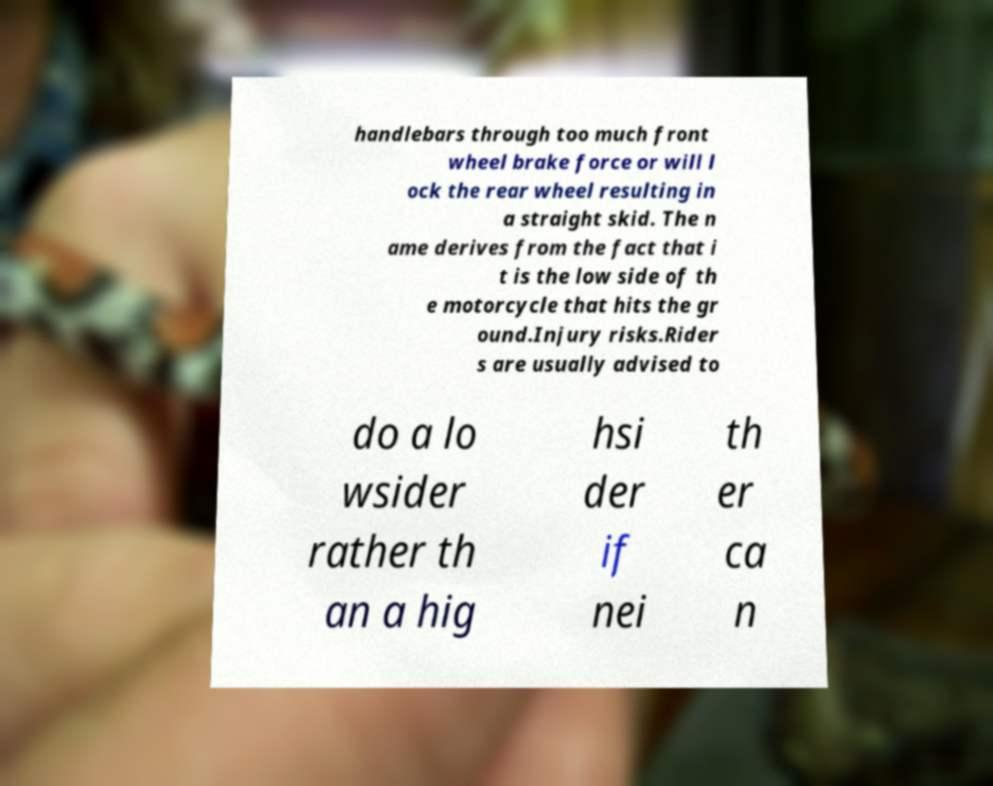I need the written content from this picture converted into text. Can you do that? handlebars through too much front wheel brake force or will l ock the rear wheel resulting in a straight skid. The n ame derives from the fact that i t is the low side of th e motorcycle that hits the gr ound.Injury risks.Rider s are usually advised to do a lo wsider rather th an a hig hsi der if nei th er ca n 